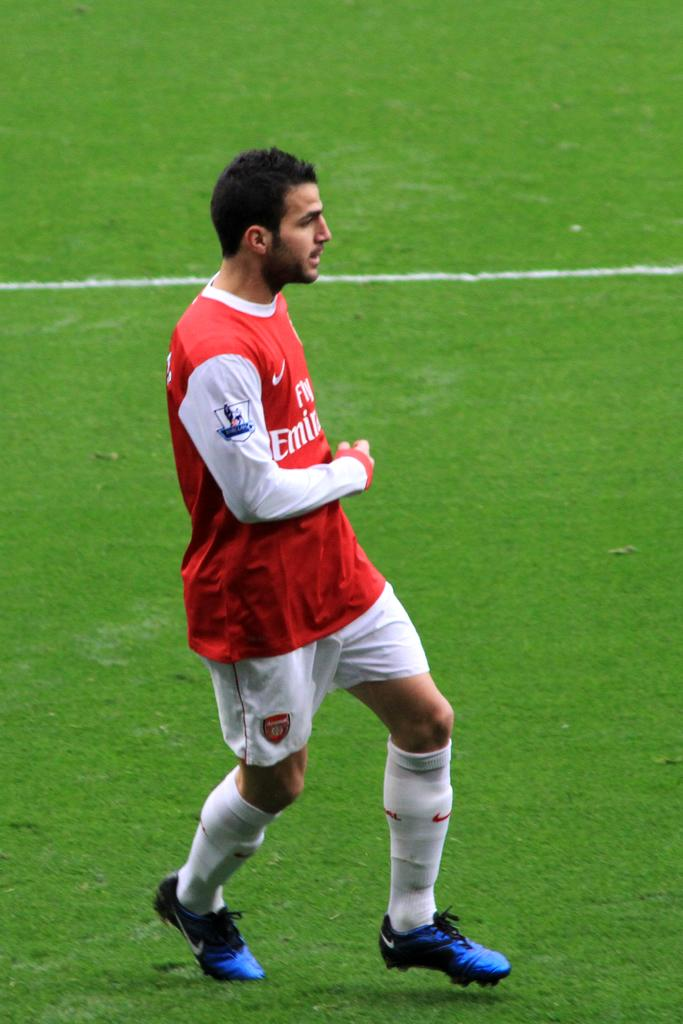What is the main subject of the image? There is a player in the image. Can you describe the player's position in the image? The player is on the ground. Reasoning: Let's think step by step by step in order to produce the conversation. We start by identifying the main subject of the image, which is the player. Then, we describe the player's position in the image, which is on the ground. We avoid yes/no questions and ensure that the language is simple and clear. Absurd Question/Answer: What route is the player taking in the image? There is no route visible in the image, as the player is on the ground and not moving. What book is the player holding in the image? There is no book present in the image; the player is the only subject visible. What book is the player holding in the image? There is no book present in the image; the player is the only subject visible. 